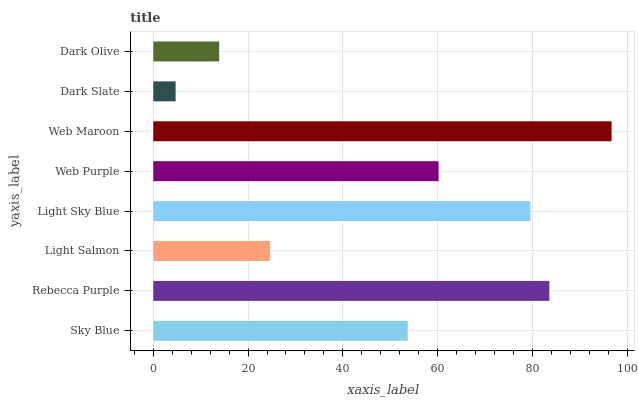Is Dark Slate the minimum?
Answer yes or no. Yes. Is Web Maroon the maximum?
Answer yes or no. Yes. Is Rebecca Purple the minimum?
Answer yes or no. No. Is Rebecca Purple the maximum?
Answer yes or no. No. Is Rebecca Purple greater than Sky Blue?
Answer yes or no. Yes. Is Sky Blue less than Rebecca Purple?
Answer yes or no. Yes. Is Sky Blue greater than Rebecca Purple?
Answer yes or no. No. Is Rebecca Purple less than Sky Blue?
Answer yes or no. No. Is Web Purple the high median?
Answer yes or no. Yes. Is Sky Blue the low median?
Answer yes or no. Yes. Is Sky Blue the high median?
Answer yes or no. No. Is Web Purple the low median?
Answer yes or no. No. 